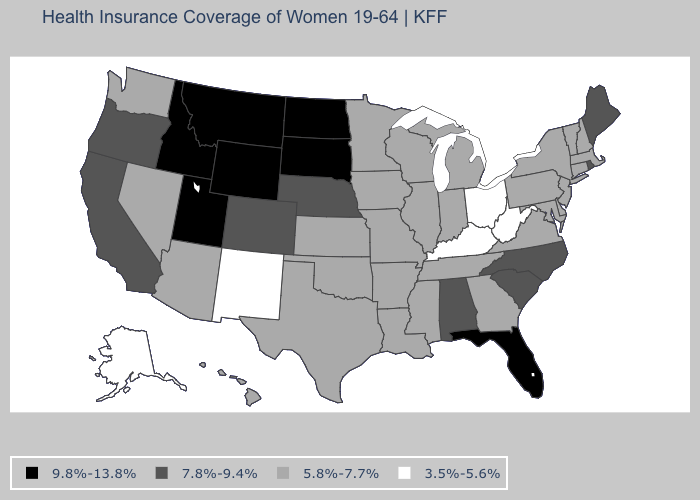What is the value of Wisconsin?
Short answer required. 5.8%-7.7%. Which states have the lowest value in the USA?
Be succinct. Alaska, Kentucky, New Mexico, Ohio, West Virginia. Does the first symbol in the legend represent the smallest category?
Write a very short answer. No. Which states have the lowest value in the USA?
Answer briefly. Alaska, Kentucky, New Mexico, Ohio, West Virginia. Is the legend a continuous bar?
Write a very short answer. No. Is the legend a continuous bar?
Be succinct. No. Among the states that border New Mexico , does Utah have the highest value?
Short answer required. Yes. What is the value of New Mexico?
Keep it brief. 3.5%-5.6%. How many symbols are there in the legend?
Give a very brief answer. 4. Name the states that have a value in the range 3.5%-5.6%?
Answer briefly. Alaska, Kentucky, New Mexico, Ohio, West Virginia. Does the map have missing data?
Answer briefly. No. Among the states that border Iowa , which have the highest value?
Concise answer only. South Dakota. How many symbols are there in the legend?
Write a very short answer. 4. Among the states that border Oregon , which have the highest value?
Keep it brief. Idaho. Name the states that have a value in the range 5.8%-7.7%?
Concise answer only. Arizona, Arkansas, Connecticut, Delaware, Georgia, Hawaii, Illinois, Indiana, Iowa, Kansas, Louisiana, Maryland, Massachusetts, Michigan, Minnesota, Mississippi, Missouri, Nevada, New Hampshire, New Jersey, New York, Oklahoma, Pennsylvania, Tennessee, Texas, Vermont, Virginia, Washington, Wisconsin. 